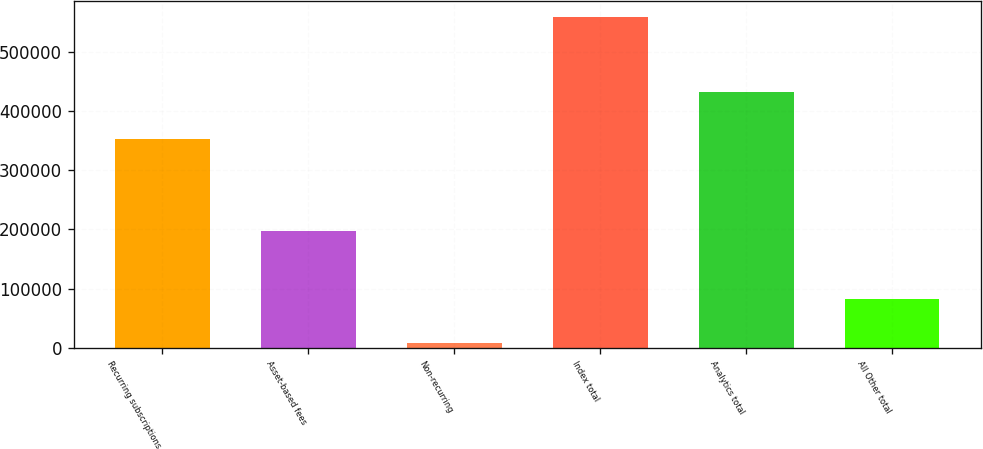Convert chart to OTSL. <chart><loc_0><loc_0><loc_500><loc_500><bar_chart><fcel>Recurring subscriptions<fcel>Asset-based fees<fcel>Non-recurring<fcel>Index total<fcel>Analytics total<fcel>All Other total<nl><fcel>353136<fcel>197974<fcel>7854<fcel>558964<fcel>433424<fcel>82625<nl></chart> 